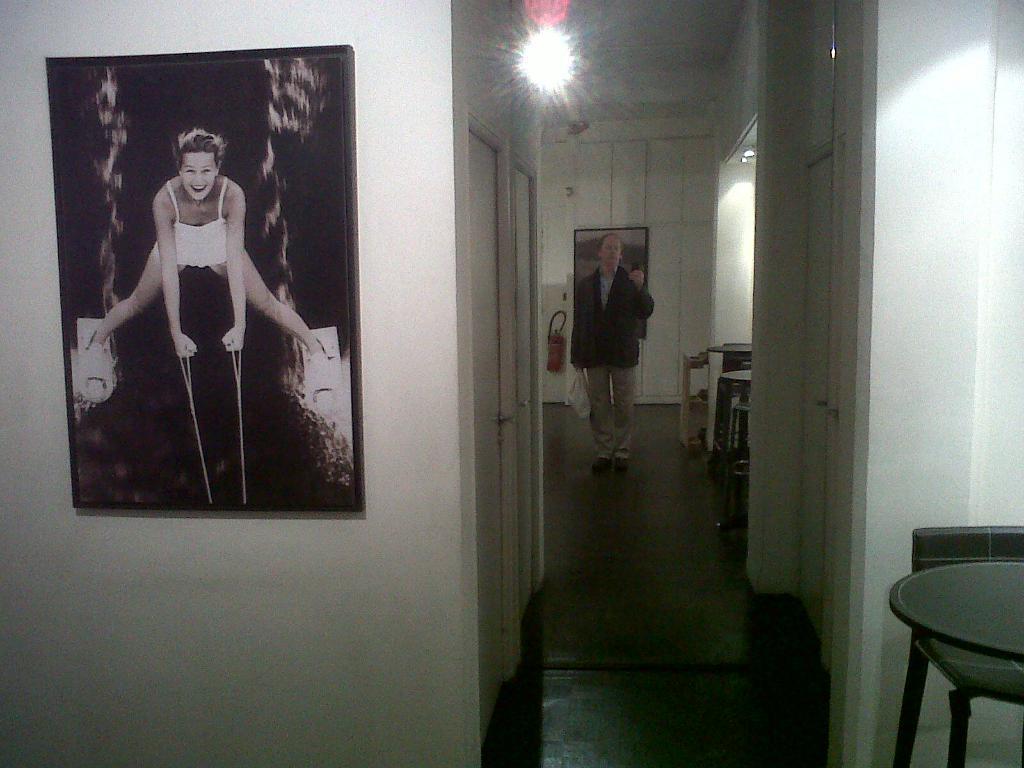Please provide a concise description of this image. In this picture I can see there is a man standing here and there is a wall here on the left and there is a photo frame on the wall and there are some doors here on the left side. 